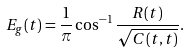<formula> <loc_0><loc_0><loc_500><loc_500>E _ { g } ( t ) = \frac { 1 } { \pi } \cos ^ { - 1 } \frac { R ( t ) } { { \sqrt { C ( t , t ) } } } .</formula> 